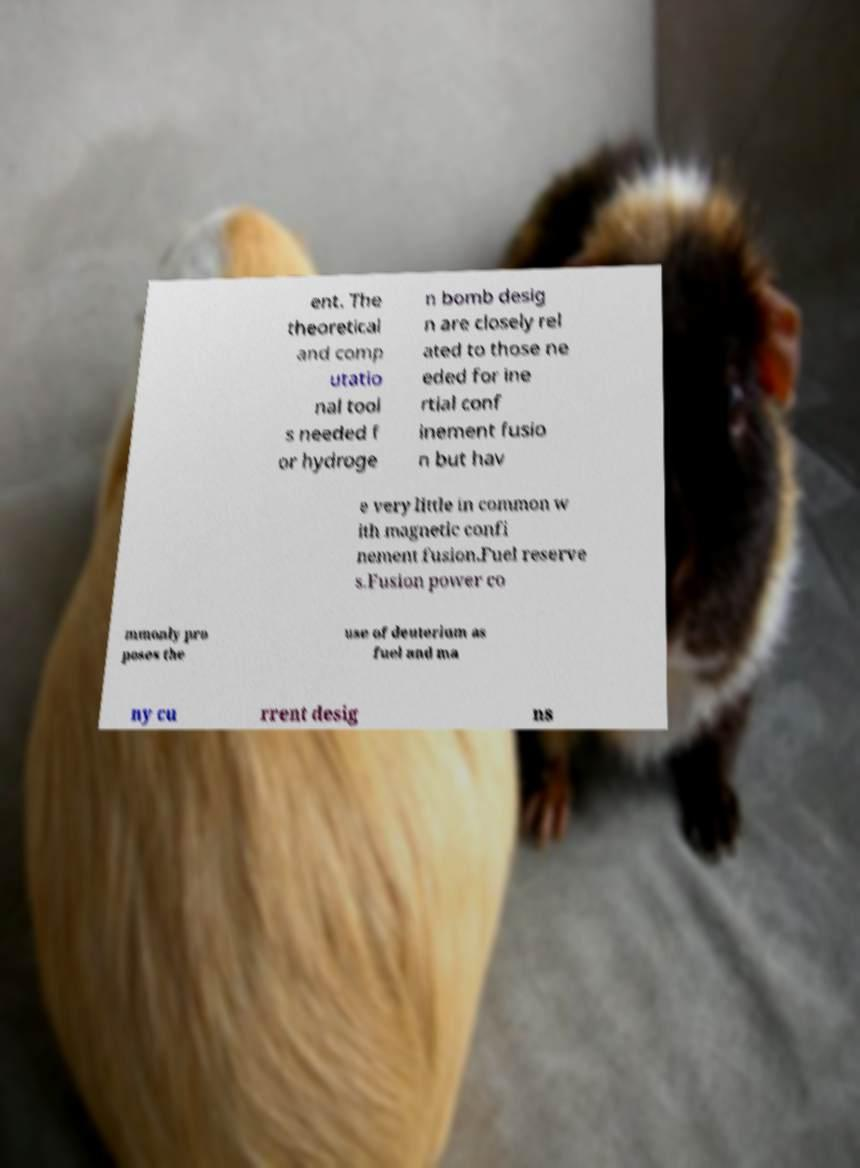Please identify and transcribe the text found in this image. ent. The theoretical and comp utatio nal tool s needed f or hydroge n bomb desig n are closely rel ated to those ne eded for ine rtial conf inement fusio n but hav e very little in common w ith magnetic confi nement fusion.Fuel reserve s.Fusion power co mmonly pro poses the use of deuterium as fuel and ma ny cu rrent desig ns 